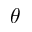<formula> <loc_0><loc_0><loc_500><loc_500>\theta</formula> 